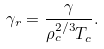Convert formula to latex. <formula><loc_0><loc_0><loc_500><loc_500>\gamma _ { r } = \frac { \gamma } { \rho ^ { 2 / 3 } _ { c } T _ { c } } .</formula> 